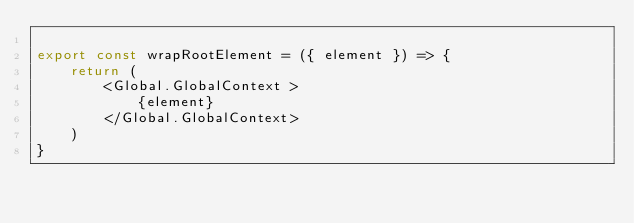Convert code to text. <code><loc_0><loc_0><loc_500><loc_500><_JavaScript_>
export const wrapRootElement = ({ element }) => {
    return (
        <Global.GlobalContext >
            {element}
        </Global.GlobalContext>
    )
}</code> 